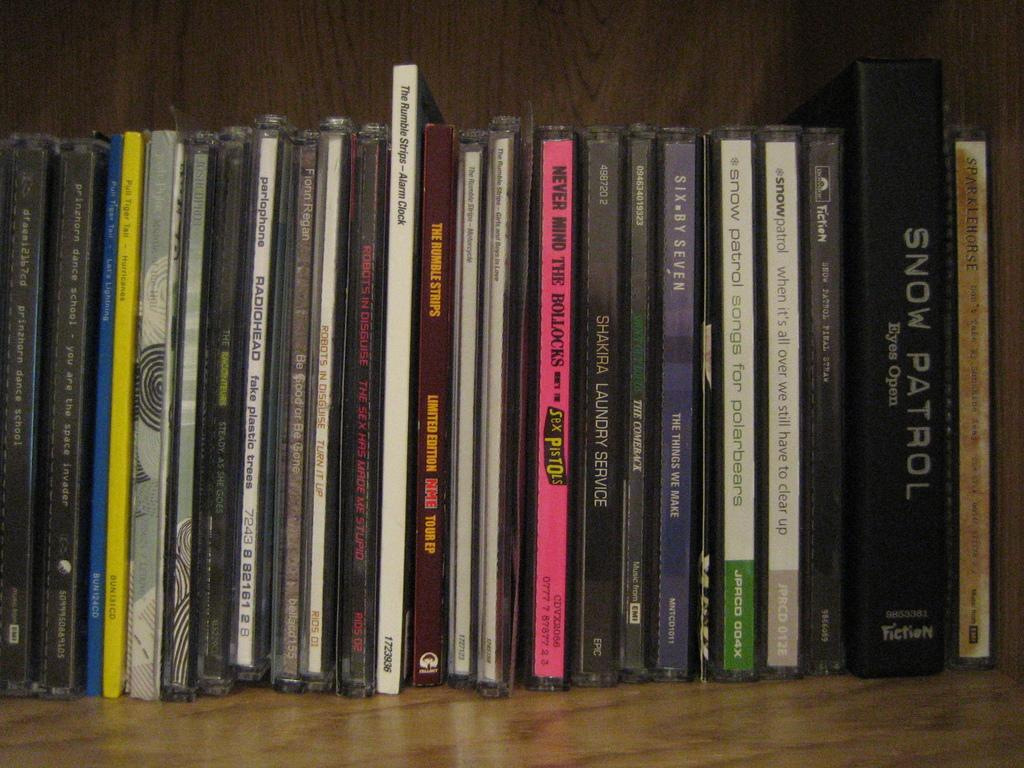<image>
Create a compact narrative representing the image presented. Stacks of music CDs for the band Snow Patrol and Sex Pistols line a wall. 